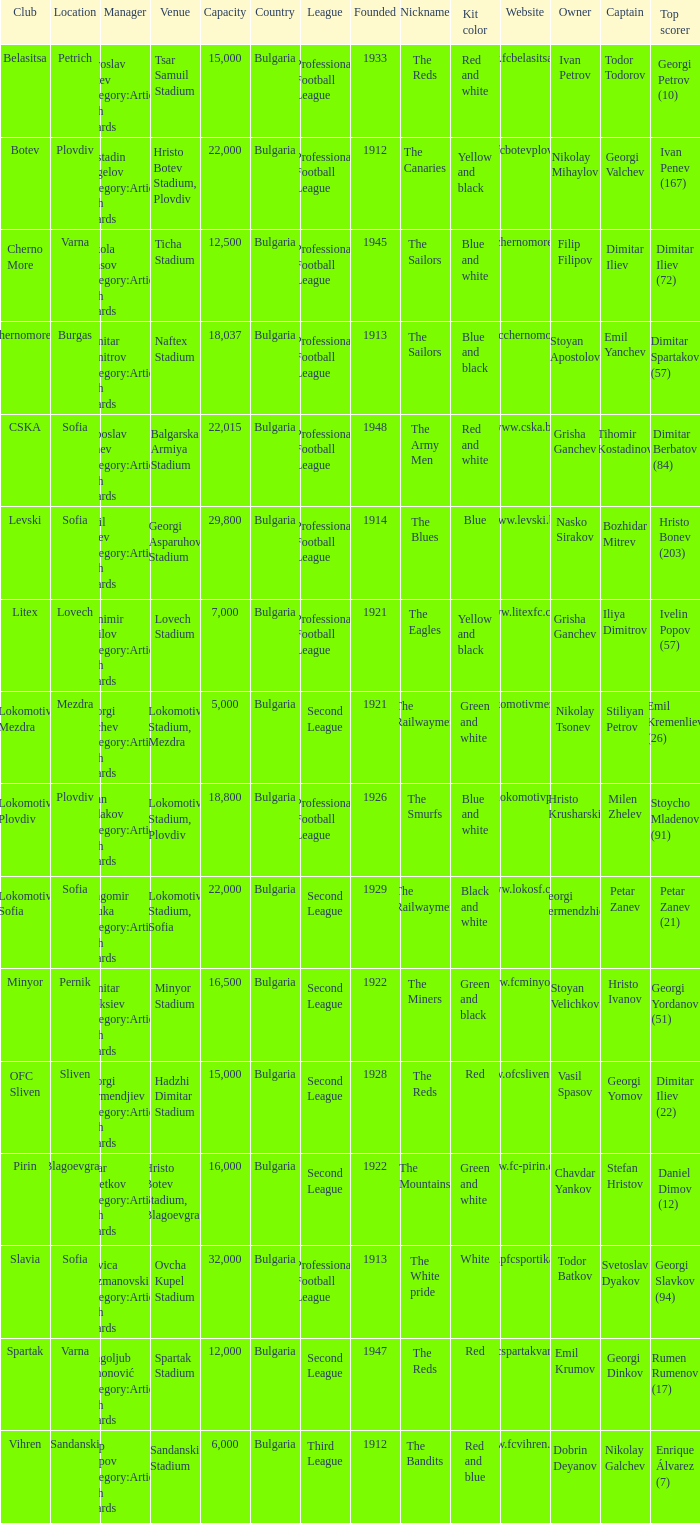What is the highest capacity for the venue of the club, vihren? 6000.0. Help me parse the entirety of this table. {'header': ['Club', 'Location', 'Manager', 'Venue', 'Capacity', 'Country', 'League', 'Founded', 'Nickname', 'Kit color', 'Website', 'Owner', 'Captain', 'Top scorer'], 'rows': [['Belasitsa', 'Petrich', 'Miroslav Mitev Category:Articles with hCards', 'Tsar Samuil Stadium', '15,000', 'Bulgaria', 'Professional Football League', '1933', 'The Reds', 'Red and white', 'www.fcbelasitsa.com', 'Ivan Petrov', 'Todor Todorov', 'Georgi Petrov (10)'], ['Botev', 'Plovdiv', 'Kostadin Angelov Category:Articles with hCards', 'Hristo Botev Stadium, Plovdiv', '22,000', 'Bulgaria', 'Professional Football League', '1912', 'The Canaries', 'Yellow and black', 'www.fcbotevplovdiv.bg', 'Nikolay Mihaylov', 'Georgi Valchev', 'Ivan Penev (167)'], ['Cherno More', 'Varna', 'Nikola Spasov Category:Articles with hCards', 'Ticha Stadium', '12,500', 'Bulgaria', 'Professional Football League', '1945', 'The Sailors', 'Blue and white', 'www.chernomorepfc.bg', 'Filip Filipov', 'Dimitar Iliev', 'Dimitar Iliev (72)'], ['Chernomorets', 'Burgas', 'Dimitar Dimitrov Category:Articles with hCards', 'Naftex Stadium', '18,037', 'Bulgaria', 'Professional Football League', '1913', 'The Sailors', 'Blue and black', 'www.fcchernomorets.bg', 'Stoyan Apostolov', 'Emil Yanchev', 'Dimitar Spartakov (57)'], ['CSKA', 'Sofia', 'Luboslav Penev Category:Articles with hCards', 'Balgarska Armiya Stadium', '22,015', 'Bulgaria', 'Professional Football League', '1948', 'The Army Men', 'Red and white', 'www.cska.bg', 'Grisha Ganchev', 'Tihomir Kostadinov', 'Dimitar Berbatov (84)'], ['Levski', 'Sofia', 'Emil Velev Category:Articles with hCards', 'Georgi Asparuhov Stadium', '29,800', 'Bulgaria', 'Professional Football League', '1914', 'The Blues', 'Blue', 'www.levski.bg', 'Nasko Sirakov', 'Bozhidar Mitrev', 'Hristo Bonev (203)'], ['Litex', 'Lovech', 'Stanimir Stoilov Category:Articles with hCards', 'Lovech Stadium', '7,000', 'Bulgaria', 'Professional Football League', '1921', 'The Eagles', 'Yellow and black', 'www.litexfc.com', 'Grisha Ganchev', 'Iliya Dimitrov', 'Ivelin Popov (57)'], ['Lokomotiv Mezdra', 'Mezdra', 'Georgi Bachev Category:Articles with hCards', 'Lokomotiv Stadium, Mezdra', '5,000', 'Bulgaria', 'Second League', '1921', 'The Railwaymen', 'Green and white', 'www.lokomotivmezdra.com', 'Nikolay Tsonev', 'Stiliyan Petrov', 'Emil Kremenliev (26)'], ['Lokomotiv Plovdiv', 'Plovdiv', 'Ayan Sadakov Category:Articles with hCards', 'Lokomotiv Stadium, Plovdiv', '18,800', 'Bulgaria', 'Professional Football League', '1926', 'The Smurfs', 'Blue and white', 'www.lokomotivpd.com', 'Hristo Krusharski', 'Milen Zhelev', 'Stoycho Mladenov (91)'], ['Lokomotiv Sofia', 'Sofia', 'Dragomir Okuka Category:Articles with hCards', 'Lokomotiv Stadium, Sofia', '22,000', 'Bulgaria', 'Second League', '1929', 'The Railwaymen', 'Black and white', 'www.lokosf.com', 'Georgi Dermendzhiev', 'Petar Zanev', 'Petar Zanev (21)'], ['Minyor', 'Pernik', 'Dimitar Aleksiev Category:Articles with hCards', 'Minyor Stadium', '16,500', 'Bulgaria', 'Second League', '1922', 'The Miners', 'Green and black', 'www.fcminyor.eu', 'Stoyan Velichkov', 'Hristo Ivanov', 'Georgi Yordanov (51)'], ['OFC Sliven', 'Sliven', 'Georgi Dermendjiev Category:Articles with hCards', 'Hadzhi Dimitar Stadium', '15,000', 'Bulgaria', 'Second League', '1928', 'The Reds', 'Red', 'www.ofcsliven.com', 'Vasil Spasov', 'Georgi Yomov', 'Dimitar Iliev (22)'], ['Pirin', 'Blagoevgrad', 'Petar Tsvetkov Category:Articles with hCards', 'Hristo Botev Stadium, Blagoevgrad', '16,000', 'Bulgaria', 'Second League', '1922', 'The Mountains', 'Green and white', 'www.fc-pirin.com', 'Chavdar Yankov', 'Stefan Hristov', 'Daniel Dimov (12)'], ['Slavia', 'Sofia', 'Stevica Kuzmanovski Category:Articles with hCards', 'Ovcha Kupel Stadium', '32,000', 'Bulgaria', 'Professional Football League', '1913', 'The White pride', 'White', 'www.pfcsportika.com', 'Todor Batkov', 'Svetoslav Dyakov', 'Georgi Slavkov (94)'], ['Spartak', 'Varna', 'Dragoljub Simonović Category:Articles with hCards', 'Spartak Stadium', '12,000', 'Bulgaria', 'Second League', '1947', 'The Reds', 'Red', 'www.fcspartakvarna.com', 'Emil Krumov', 'Georgi Dinkov', 'Rumen Rumenov (17)'], ['Vihren', 'Sandanski', 'Filip Filipov Category:Articles with hCards', 'Sandanski Stadium', '6,000', 'Bulgaria', 'Third League', '1912', 'The Bandits', 'Red and blue', 'www.fcvihren.com', 'Dobrin Deyanov', 'Nikolay Galchev', 'Enrique Álvarez (7)']]} 